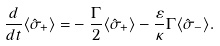Convert formula to latex. <formula><loc_0><loc_0><loc_500><loc_500>\frac { d } { d t } \langle \hat { \sigma } _ { + } \rangle = & - \frac { \Gamma } { 2 } \langle \hat { \sigma } _ { + } \rangle - \frac { \varepsilon } { \kappa } \Gamma \langle \hat { \sigma } _ { - } \rangle .</formula> 